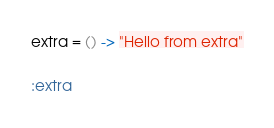<code> <loc_0><loc_0><loc_500><loc_500><_MoonScript_>extra = () -> "Hello from extra"

:extra
</code> 